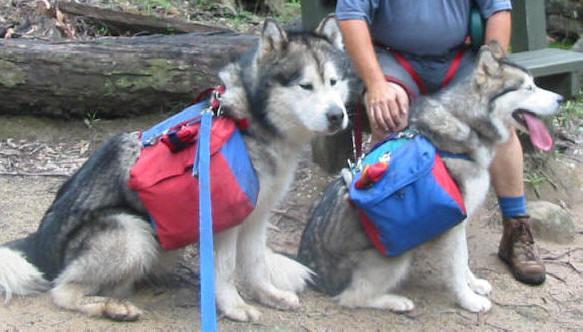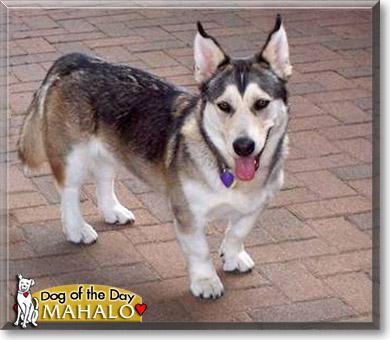The first image is the image on the left, the second image is the image on the right. Considering the images on both sides, is "At least one of the dogs does not have a backpack on its back." valid? Answer yes or no. Yes. The first image is the image on the left, the second image is the image on the right. Considering the images on both sides, is "In the left image, two furry dogs are seen wearing packs on their backs." valid? Answer yes or no. Yes. 